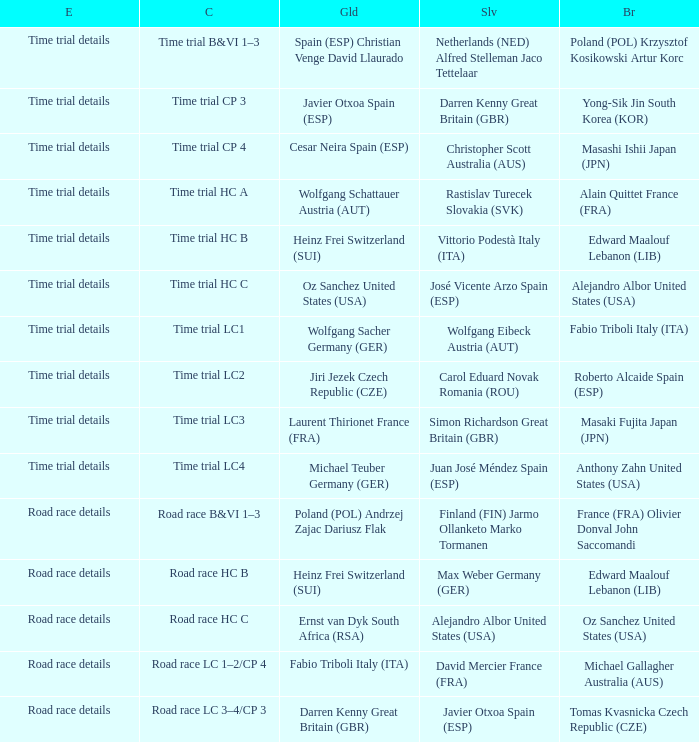Who received gold when the event is time trial details and silver is simon richardson great britain (gbr)? Laurent Thirionet France (FRA). 